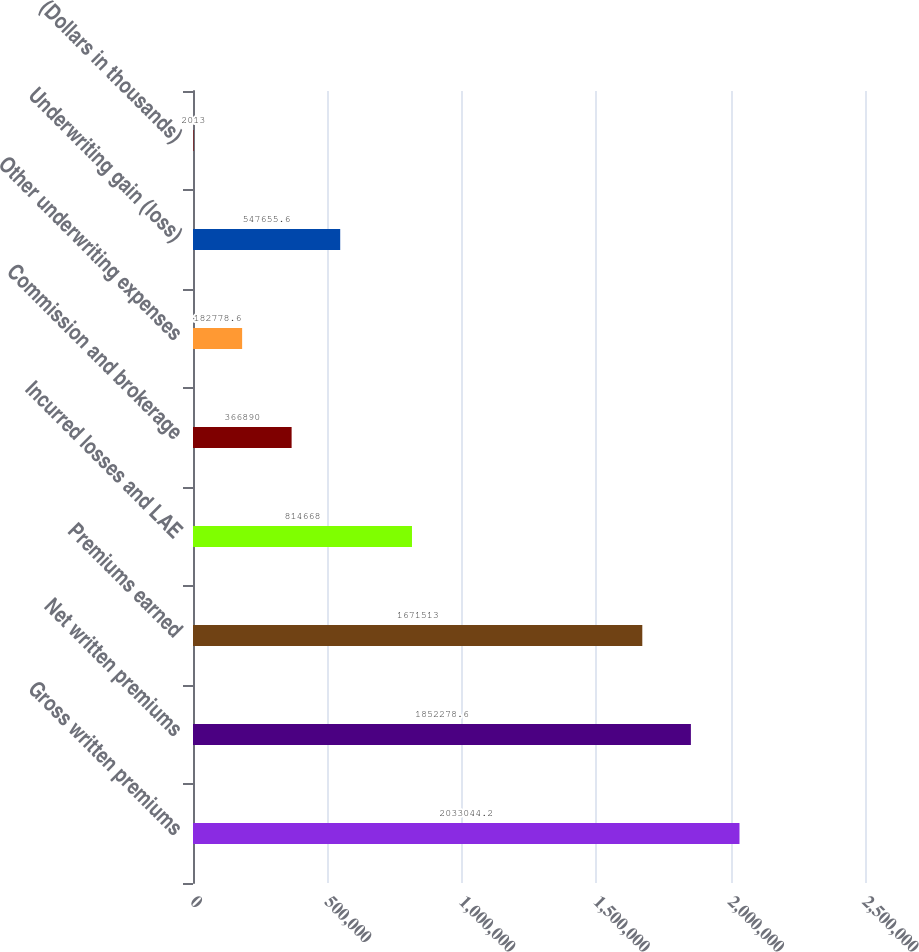Convert chart. <chart><loc_0><loc_0><loc_500><loc_500><bar_chart><fcel>Gross written premiums<fcel>Net written premiums<fcel>Premiums earned<fcel>Incurred losses and LAE<fcel>Commission and brokerage<fcel>Other underwriting expenses<fcel>Underwriting gain (loss)<fcel>(Dollars in thousands)<nl><fcel>2.03304e+06<fcel>1.85228e+06<fcel>1.67151e+06<fcel>814668<fcel>366890<fcel>182779<fcel>547656<fcel>2013<nl></chart> 